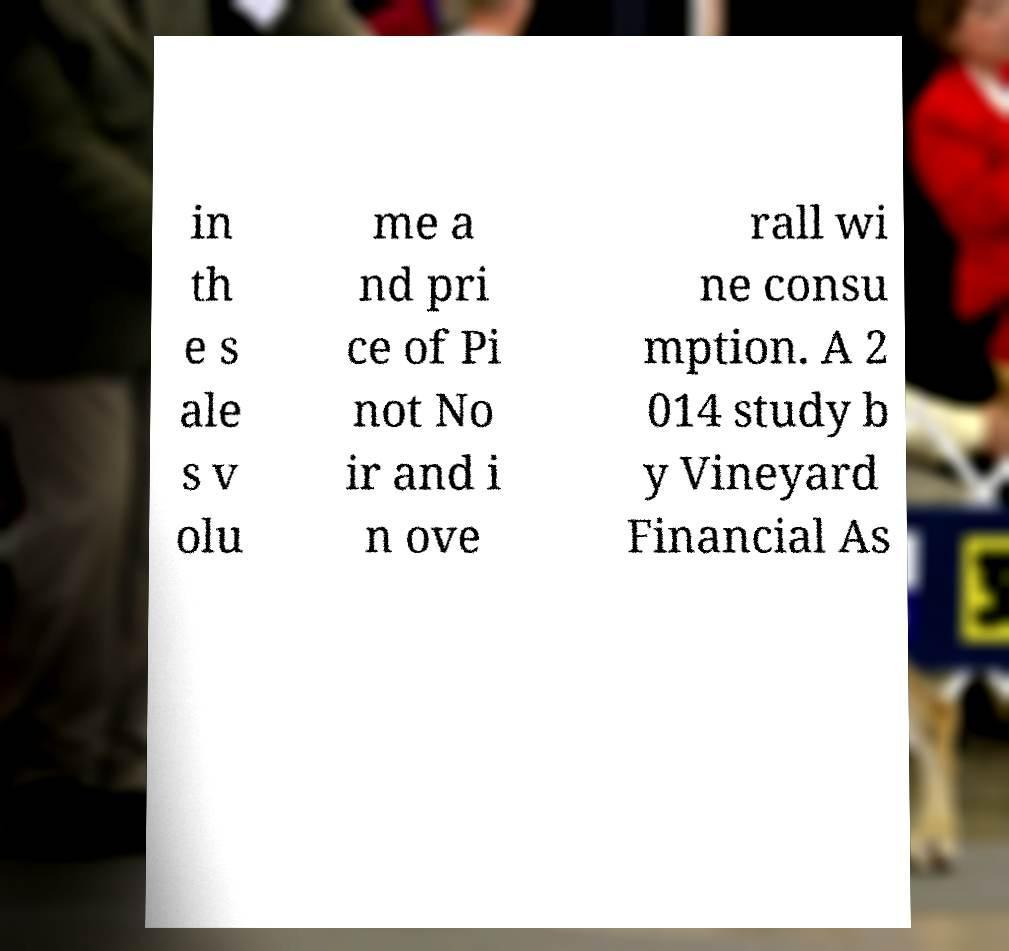Please read and relay the text visible in this image. What does it say? in th e s ale s v olu me a nd pri ce of Pi not No ir and i n ove rall wi ne consu mption. A 2 014 study b y Vineyard Financial As 